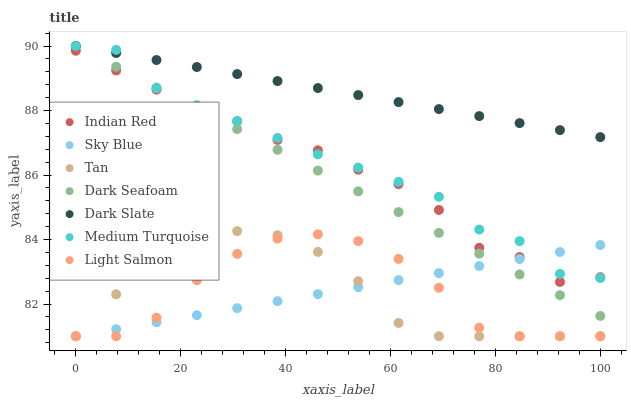Does Tan have the minimum area under the curve?
Answer yes or no. Yes. Does Dark Slate have the maximum area under the curve?
Answer yes or no. Yes. Does Indian Red have the minimum area under the curve?
Answer yes or no. No. Does Indian Red have the maximum area under the curve?
Answer yes or no. No. Is Dark Slate the smoothest?
Answer yes or no. Yes. Is Light Salmon the roughest?
Answer yes or no. Yes. Is Indian Red the smoothest?
Answer yes or no. No. Is Indian Red the roughest?
Answer yes or no. No. Does Light Salmon have the lowest value?
Answer yes or no. Yes. Does Indian Red have the lowest value?
Answer yes or no. No. Does Medium Turquoise have the highest value?
Answer yes or no. Yes. Does Indian Red have the highest value?
Answer yes or no. No. Is Tan less than Dark Slate?
Answer yes or no. Yes. Is Dark Slate greater than Indian Red?
Answer yes or no. Yes. Does Sky Blue intersect Tan?
Answer yes or no. Yes. Is Sky Blue less than Tan?
Answer yes or no. No. Is Sky Blue greater than Tan?
Answer yes or no. No. Does Tan intersect Dark Slate?
Answer yes or no. No. 